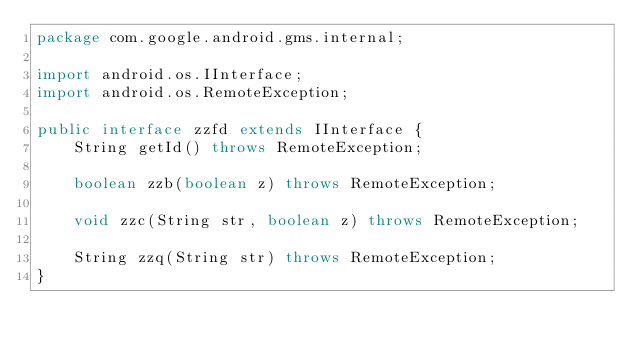<code> <loc_0><loc_0><loc_500><loc_500><_Java_>package com.google.android.gms.internal;

import android.os.IInterface;
import android.os.RemoteException;

public interface zzfd extends IInterface {
    String getId() throws RemoteException;

    boolean zzb(boolean z) throws RemoteException;

    void zzc(String str, boolean z) throws RemoteException;

    String zzq(String str) throws RemoteException;
}
</code> 